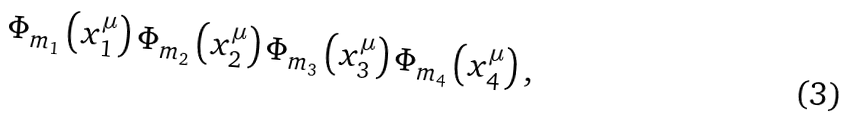Convert formula to latex. <formula><loc_0><loc_0><loc_500><loc_500>\Phi _ { m _ { 1 } } \left ( x ^ { \mu } _ { 1 } \right ) \Phi _ { m _ { 2 } } \left ( x ^ { \mu } _ { 2 } \right ) \Phi _ { m _ { 3 } } \left ( x ^ { \mu } _ { 3 } \right ) \Phi _ { m _ { 4 } } \left ( x ^ { \mu } _ { 4 } \right ) ,</formula> 